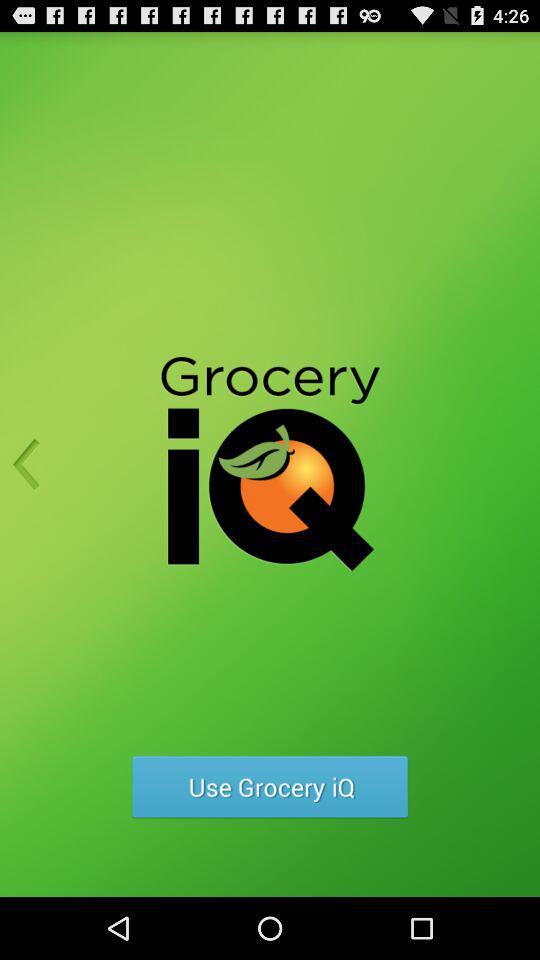What is the name of the application? the name of the application is "Grocery iQ". 